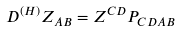<formula> <loc_0><loc_0><loc_500><loc_500>D ^ { ( H ) } Z _ { A B } = Z ^ { C D } P _ { C D A B }</formula> 